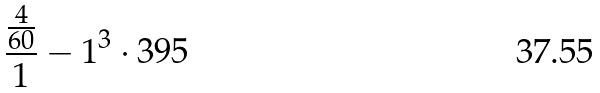Convert formula to latex. <formula><loc_0><loc_0><loc_500><loc_500>\frac { \frac { 4 } { 6 0 } } { 1 } - 1 ^ { 3 } \cdot 3 9 5</formula> 